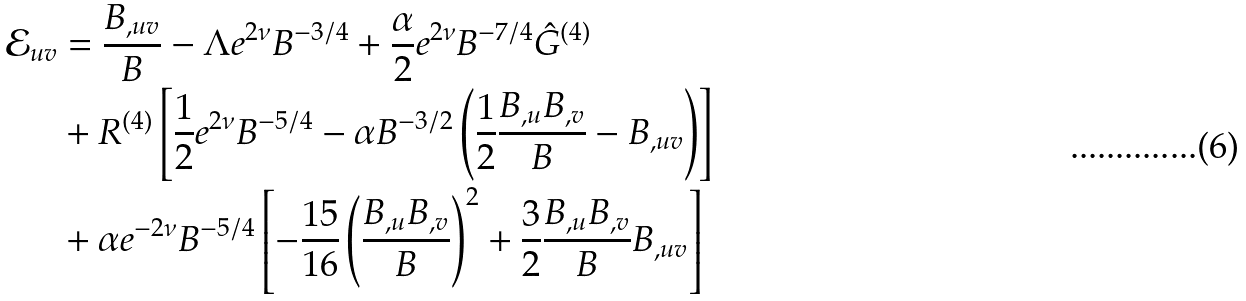<formula> <loc_0><loc_0><loc_500><loc_500>\mathcal { E } _ { u v } & = \frac { { B _ { , u v } } } { B } - \Lambda e ^ { 2 \nu } B ^ { - 3 / 4 } + \frac { \alpha } { 2 } e ^ { 2 \nu } B ^ { - 7 / 4 } \hat { G } ^ { ( 4 ) } \\ & + R ^ { ( 4 ) } \left [ { \frac { 1 } { 2 } e ^ { 2 \nu } B ^ { - 5 / 4 } - \alpha B ^ { - 3 / 2 } \left ( { \frac { 1 } { 2 } \frac { { B _ { , u } B _ { , v } } } { B } - B _ { , u v } } \right ) } \right ] \\ & + \alpha e ^ { - 2 \nu } B ^ { - 5 / 4 } \left [ { - \frac { 1 5 } { 1 6 } \left ( { \frac { { B _ { , u } B _ { , v } } } { B } } \right ) ^ { 2 } + \frac { 3 } { 2 } \frac { { B _ { , u } B _ { , v } } } { B } B _ { , u v } } \right ]</formula> 